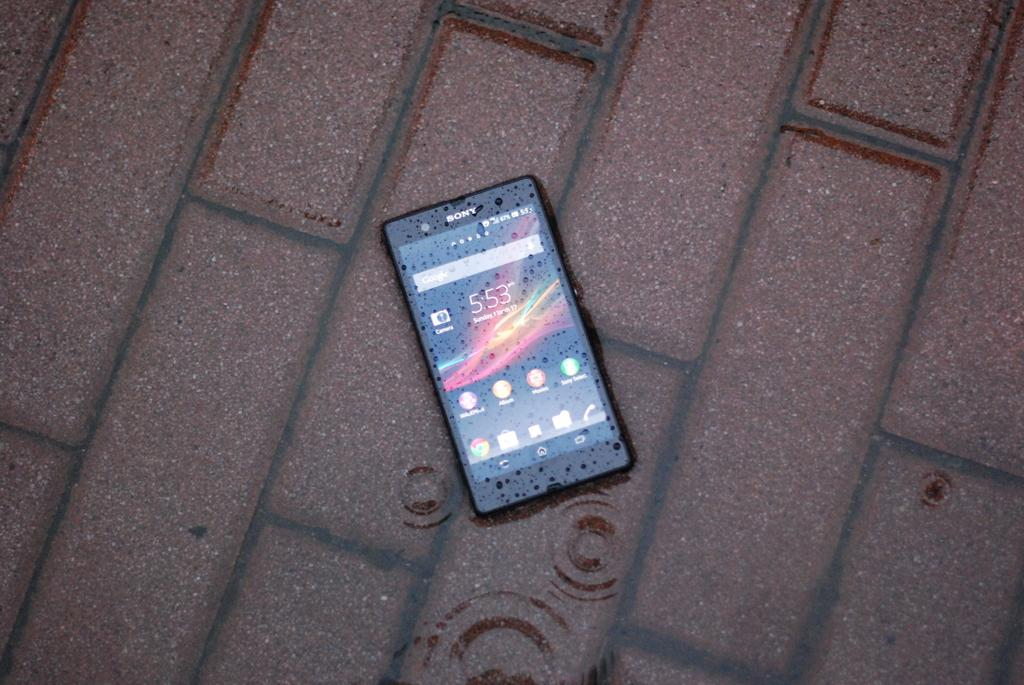<image>
Write a terse but informative summary of the picture. The Sony cell phone is displaying time 5:53. 